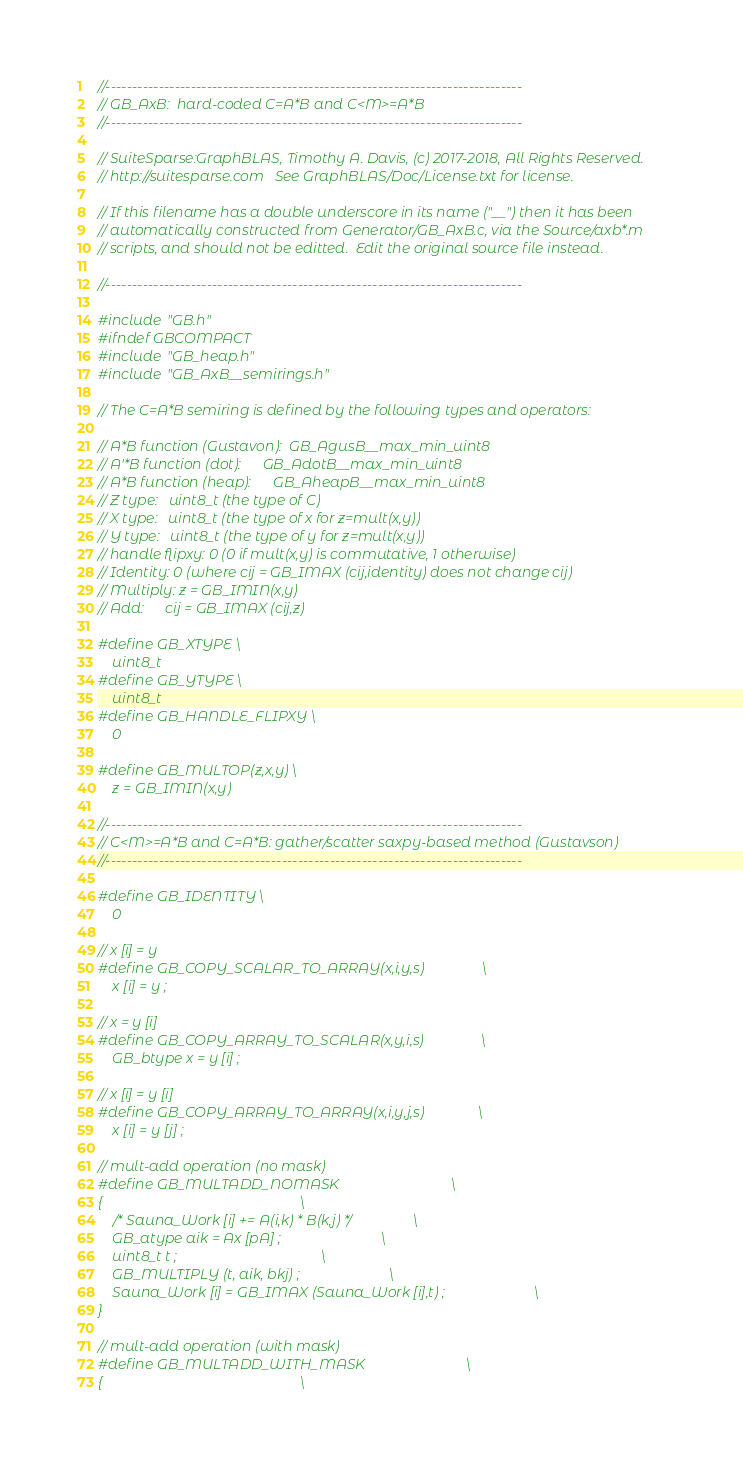Convert code to text. <code><loc_0><loc_0><loc_500><loc_500><_C_>


//------------------------------------------------------------------------------
// GB_AxB:  hard-coded C=A*B and C<M>=A*B
//------------------------------------------------------------------------------

// SuiteSparse:GraphBLAS, Timothy A. Davis, (c) 2017-2018, All Rights Reserved.
// http://suitesparse.com   See GraphBLAS/Doc/License.txt for license.

// If this filename has a double underscore in its name ("__") then it has been
// automatically constructed from Generator/GB_AxB.c, via the Source/axb*.m
// scripts, and should not be editted.  Edit the original source file instead.

//------------------------------------------------------------------------------

#include "GB.h"
#ifndef GBCOMPACT
#include "GB_heap.h"
#include "GB_AxB__semirings.h"

// The C=A*B semiring is defined by the following types and operators:

// A*B function (Gustavon):  GB_AgusB__max_min_uint8
// A'*B function (dot):      GB_AdotB__max_min_uint8
// A*B function (heap):      GB_AheapB__max_min_uint8
// Z type:   uint8_t (the type of C)
// X type:   uint8_t (the type of x for z=mult(x,y))
// Y type:   uint8_t (the type of y for z=mult(x,y))
// handle flipxy: 0 (0 if mult(x,y) is commutative, 1 otherwise)
// Identity: 0 (where cij = GB_IMAX (cij,identity) does not change cij)
// Multiply: z = GB_IMIN(x,y)
// Add:      cij = GB_IMAX (cij,z)

#define GB_XTYPE \
    uint8_t
#define GB_YTYPE \
    uint8_t
#define GB_HANDLE_FLIPXY \
    0

#define GB_MULTOP(z,x,y) \
    z = GB_IMIN(x,y)

//------------------------------------------------------------------------------
// C<M>=A*B and C=A*B: gather/scatter saxpy-based method (Gustavson)
//------------------------------------------------------------------------------

#define GB_IDENTITY \
    0

// x [i] = y
#define GB_COPY_SCALAR_TO_ARRAY(x,i,y,s)                \
    x [i] = y ;

// x = y [i]
#define GB_COPY_ARRAY_TO_SCALAR(x,y,i,s)                \
    GB_btype x = y [i] ;

// x [i] = y [i]
#define GB_COPY_ARRAY_TO_ARRAY(x,i,y,j,s)               \
    x [i] = y [j] ;

// mult-add operation (no mask)
#define GB_MULTADD_NOMASK                               \
{                                                       \
    /* Sauna_Work [i] += A(i,k) * B(k,j) */             \
    GB_atype aik = Ax [pA] ;                            \
    uint8_t t ;                                        \
    GB_MULTIPLY (t, aik, bkj) ;                         \
    Sauna_Work [i] = GB_IMAX (Sauna_Work [i],t) ;                         \
}

// mult-add operation (with mask)
#define GB_MULTADD_WITH_MASK                            \
{                                                       \</code> 